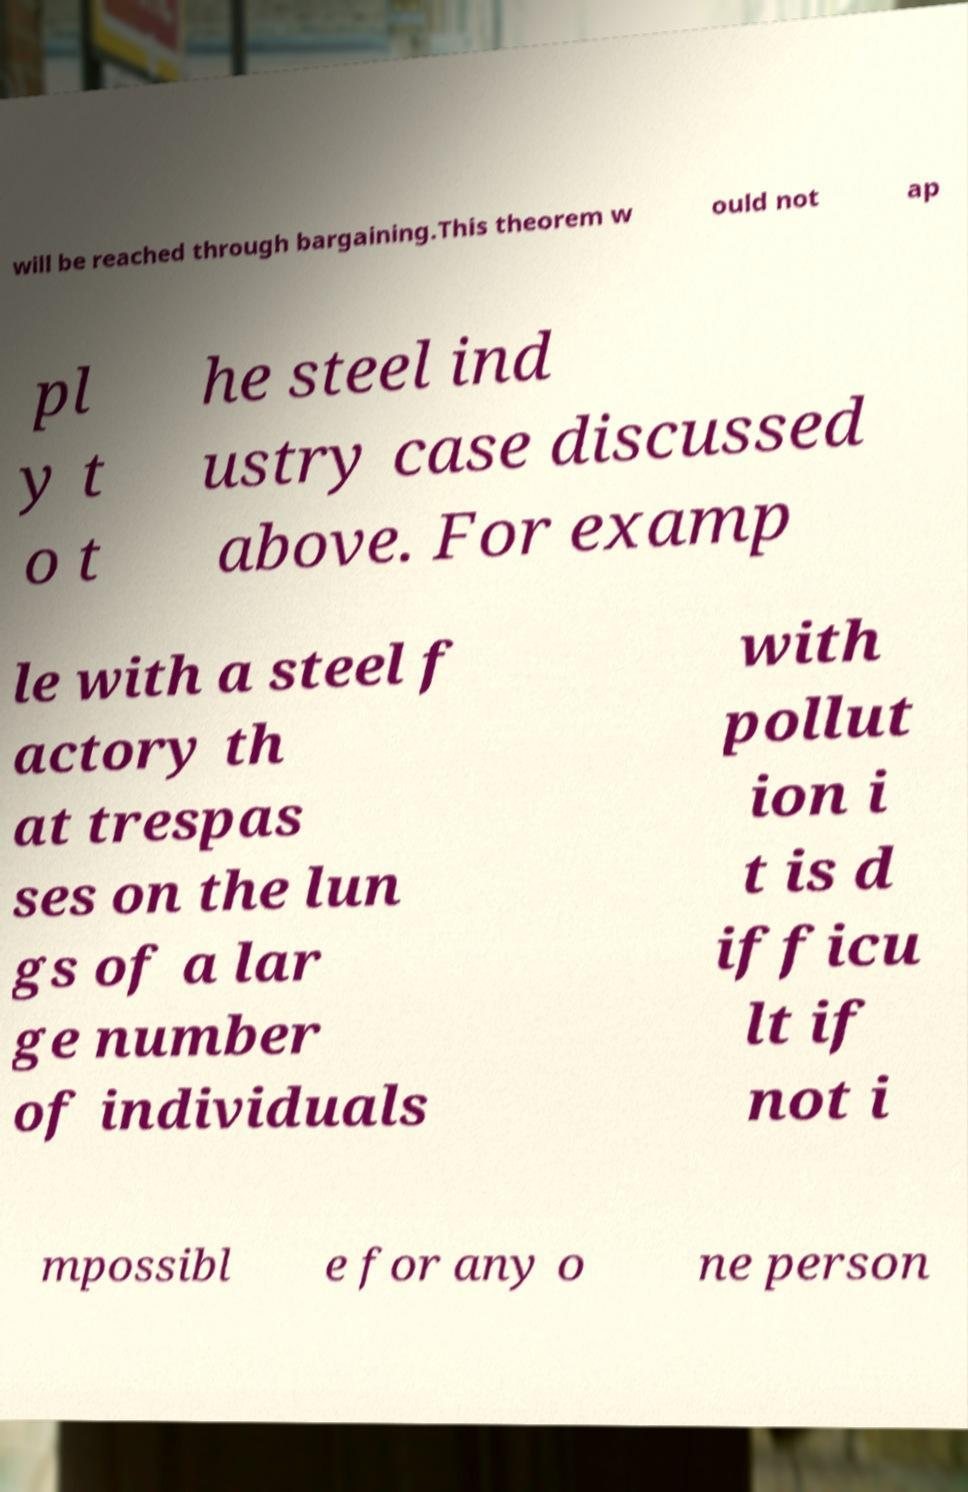Could you extract and type out the text from this image? will be reached through bargaining.This theorem w ould not ap pl y t o t he steel ind ustry case discussed above. For examp le with a steel f actory th at trespas ses on the lun gs of a lar ge number of individuals with pollut ion i t is d ifficu lt if not i mpossibl e for any o ne person 